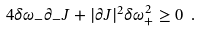<formula> <loc_0><loc_0><loc_500><loc_500>4 \delta \omega _ { - } \partial _ { - } J + | \partial J | ^ { 2 } { \delta \omega _ { + } ^ { 2 } } \geq 0 \ .</formula> 